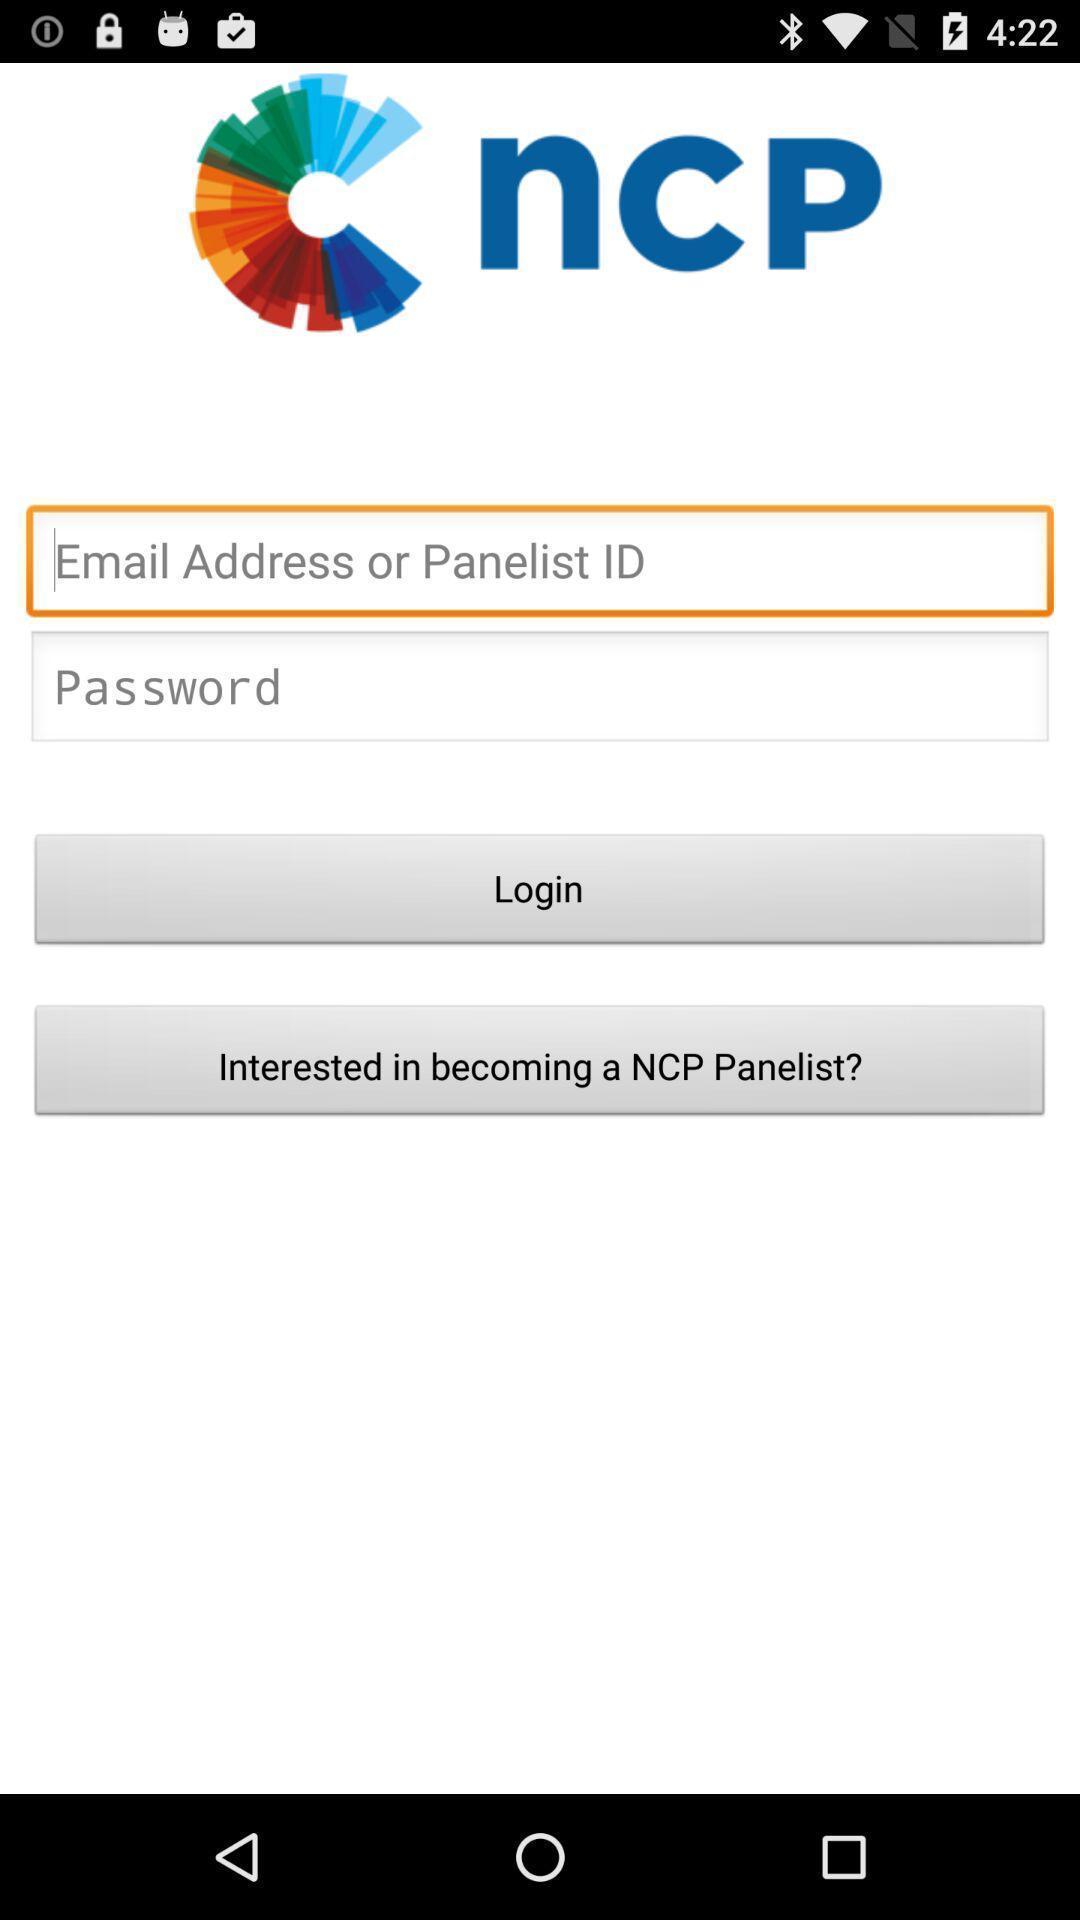Give me a summary of this screen capture. Login page. 